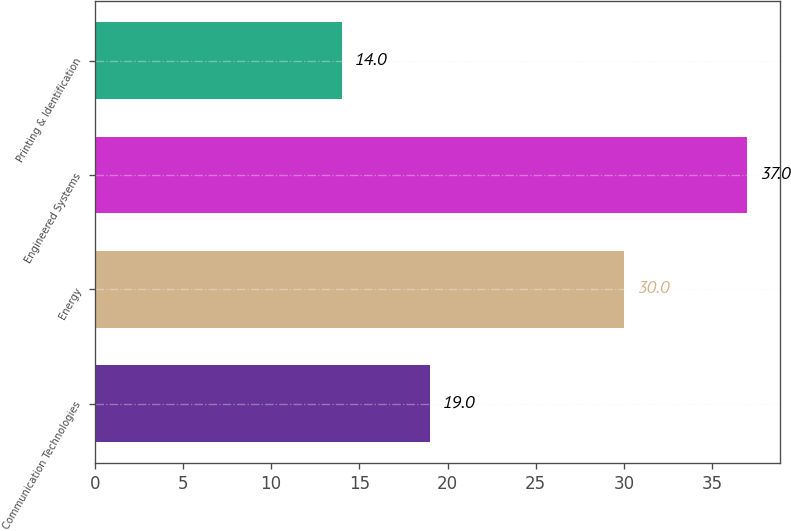<chart> <loc_0><loc_0><loc_500><loc_500><bar_chart><fcel>Communication Technologies<fcel>Energy<fcel>Engineered Systems<fcel>Printing & Identification<nl><fcel>19<fcel>30<fcel>37<fcel>14<nl></chart> 